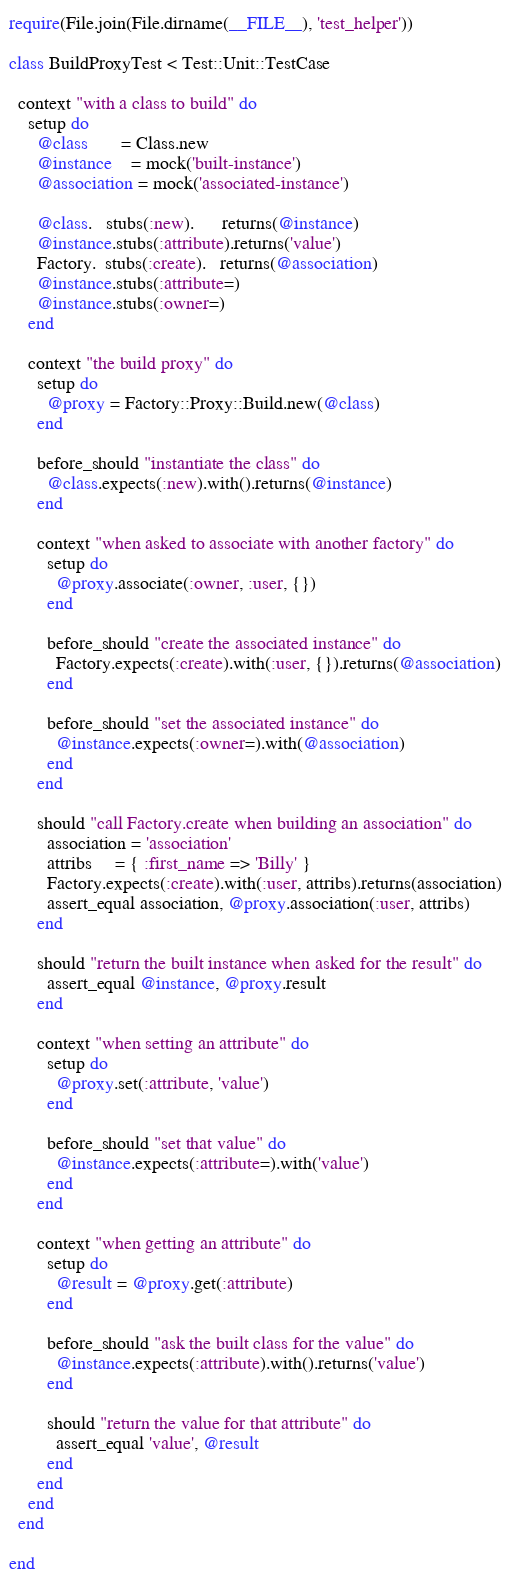Convert code to text. <code><loc_0><loc_0><loc_500><loc_500><_Ruby_>require(File.join(File.dirname(__FILE__), 'test_helper'))

class BuildProxyTest < Test::Unit::TestCase

  context "with a class to build" do
    setup do
      @class       = Class.new
      @instance    = mock('built-instance')
      @association = mock('associated-instance')

      @class.   stubs(:new).      returns(@instance)
      @instance.stubs(:attribute).returns('value')
      Factory.  stubs(:create).   returns(@association)
      @instance.stubs(:attribute=)
      @instance.stubs(:owner=)
    end

    context "the build proxy" do
      setup do
        @proxy = Factory::Proxy::Build.new(@class)
      end

      before_should "instantiate the class" do
        @class.expects(:new).with().returns(@instance)
      end

      context "when asked to associate with another factory" do
        setup do
          @proxy.associate(:owner, :user, {})
        end

        before_should "create the associated instance" do
          Factory.expects(:create).with(:user, {}).returns(@association)
        end

        before_should "set the associated instance" do
          @instance.expects(:owner=).with(@association)
        end
      end

      should "call Factory.create when building an association" do
        association = 'association'
        attribs     = { :first_name => 'Billy' }
        Factory.expects(:create).with(:user, attribs).returns(association)
        assert_equal association, @proxy.association(:user, attribs)
      end

      should "return the built instance when asked for the result" do
        assert_equal @instance, @proxy.result
      end

      context "when setting an attribute" do
        setup do
          @proxy.set(:attribute, 'value')
        end

        before_should "set that value" do
          @instance.expects(:attribute=).with('value')
        end
      end

      context "when getting an attribute" do
        setup do
          @result = @proxy.get(:attribute)
        end

        before_should "ask the built class for the value" do
          @instance.expects(:attribute).with().returns('value')
        end

        should "return the value for that attribute" do
          assert_equal 'value', @result
        end
      end
    end
  end

end

</code> 